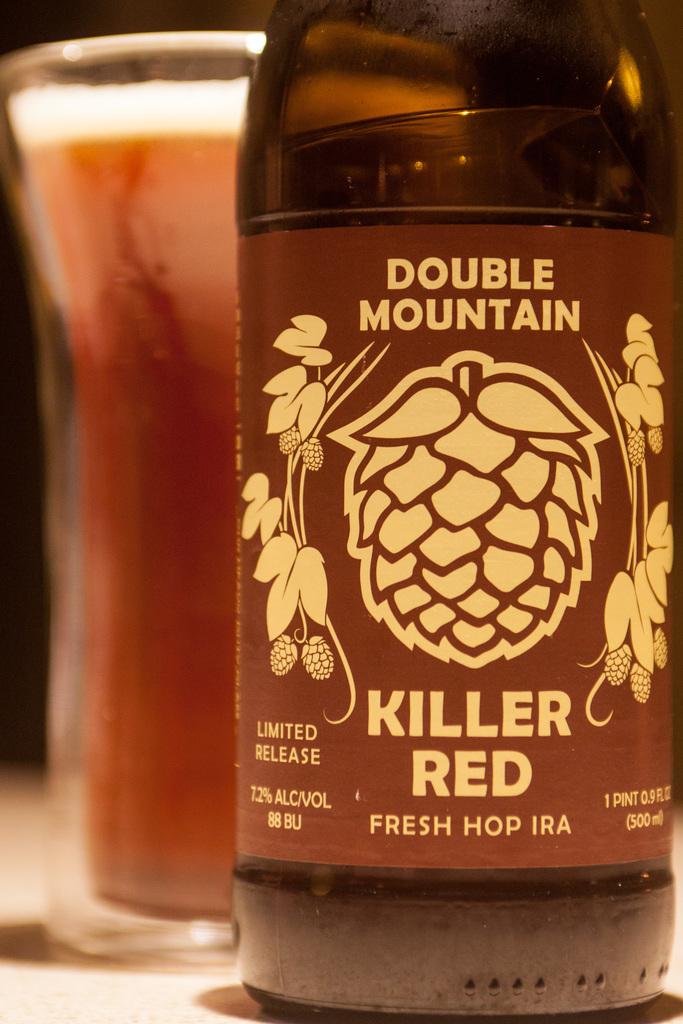Is this an ipa?
Make the answer very short. Yes. 